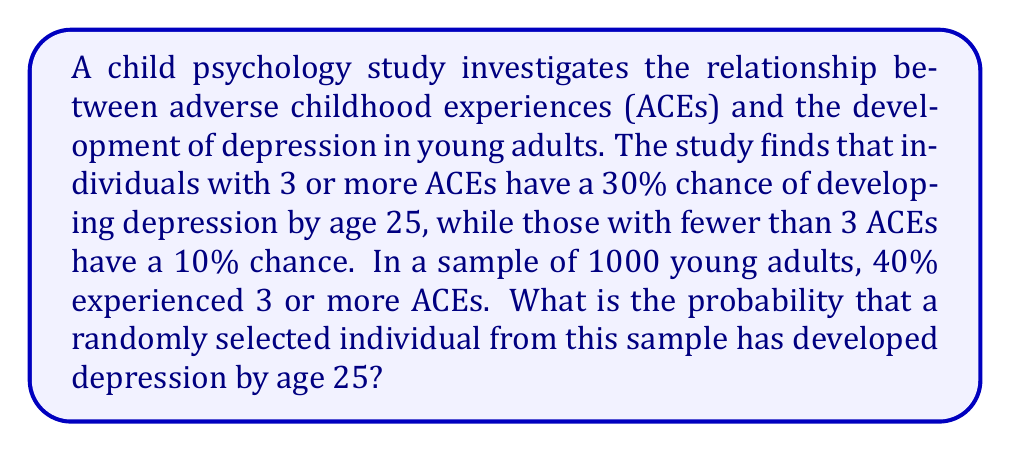Could you help me with this problem? Let's approach this step-by-step using the law of total probability:

1) Define events:
   A: Individual has 3 or more ACEs
   B: Individual develops depression by age 25

2) Given probabilities:
   P(A) = 0.40 (40% of the sample experienced 3 or more ACEs)
   P(B|A) = 0.30 (30% chance of depression if 3 or more ACEs)
   P(B|not A) = 0.10 (10% chance of depression if fewer than 3 ACEs)

3) We need to find P(B). The law of total probability states:
   $$P(B) = P(B|A) \cdot P(A) + P(B|\text{not }A) \cdot P(\text{not }A)$$

4) Calculate P(not A):
   $$P(\text{not }A) = 1 - P(A) = 1 - 0.40 = 0.60$$

5) Now, let's substitute the values into the formula:
   $$P(B) = 0.30 \cdot 0.40 + 0.10 \cdot 0.60$$

6) Calculate:
   $$P(B) = 0.12 + 0.06 = 0.18$$

Therefore, the probability that a randomly selected individual from this sample has developed depression by age 25 is 0.18 or 18%.
Answer: 0.18 or 18% 